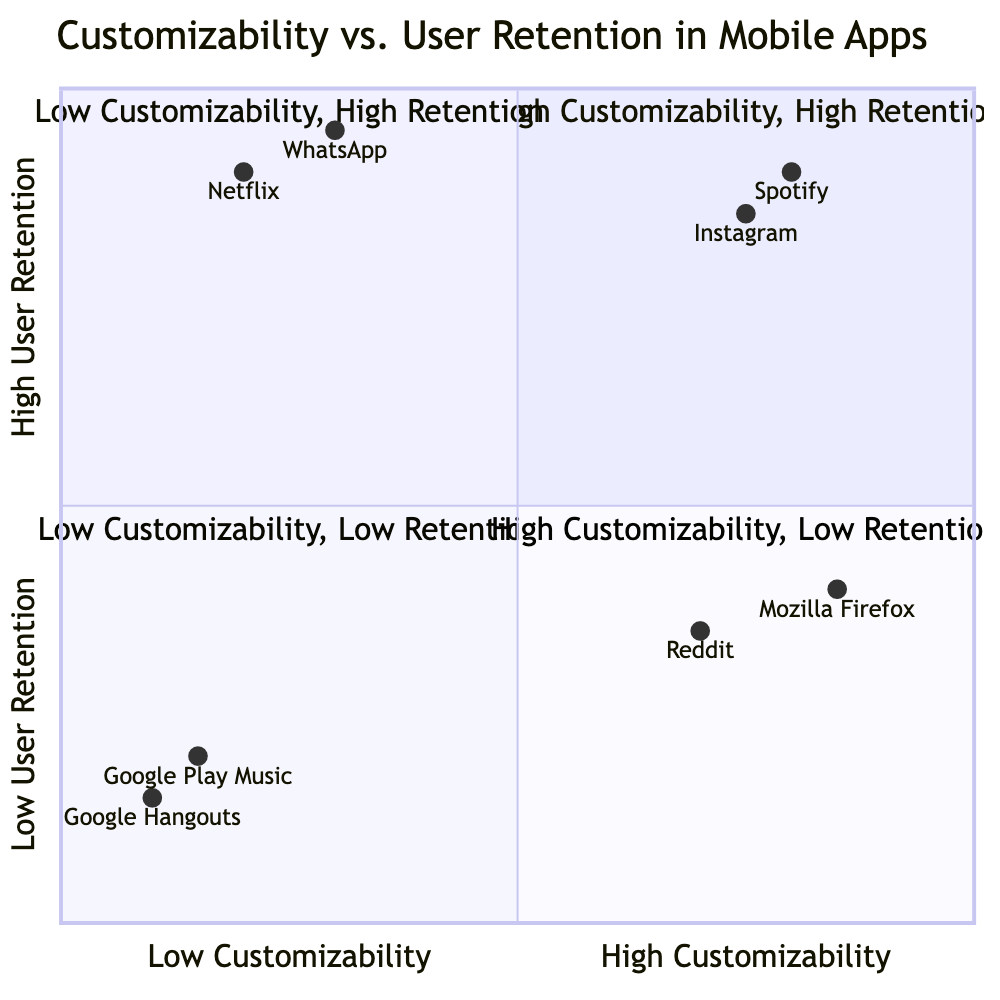What is the name of the app with high customizability and high user retention? The quadrant representing high customizability and high user retention contains the apps Spotify and Instagram.
Answer: Spotify, Instagram Which app shows high customizability but low user retention? The high customizability and low user retention quadrant includes Mozilla Firefox and Reddit.
Answer: Mozilla Firefox, Reddit How many apps are located in the low customizability and low user retention quadrant? The low customizability and low user retention quadrant features two apps: Google Play Music and Google Hangouts. This makes a total of 2 apps in this quadrant.
Answer: 2 What customization factor is provided by WhatsApp? WhatsApp's customizability factors include chat backgrounds and notification tones, but the specific customization factor asked for is chat backgrounds.
Answer: Chat Backgrounds What is the primary retention factor for Netflix? Netflix is known for its original content, which contributes significantly to user retention, along with a wide selection and high streaming quality. The answer sought here is original content.
Answer: Original Content How does Mozilla Firefox's user retention compare to Reddit's? Mozilla Firefox has lower user retention compared to Reddit, with retention factors influenced by security concerns and speed issues, while Reddit faces challenges due to toxicity in communities and an overwhelming interface. Since the question asks for the comparison, the answer is that Mozilla Firefox provides low user retention, and it is less than that of Reddit.
Answer: Lower Name the app in the low customizability and high user retention quadrant. The low customizability but high user retention quadrant contains WhatsApp and Netflix. The answer requested is the first one mentioned, which is WhatsApp.
Answer: WhatsApp What are the customizability factors for Instagram? Instagram offers several customizability factors, mainly filters, story highlights, and profile themes. The customizability factors of interest here are filters, story highlights, and profile themes.
Answer: Filters, Story Highlights, Profile Themes Which quadrant includes Google Hangouts? Google Hangouts is found in the low customizability and low user retention quadrant, alongside Google Play Music. The question asks for the specific quadrant, so the answer is low customizability, low user retention.
Answer: Low Customizability, Low User Retention What common factor affects both Mozilla Firefox and Reddit's user retention? Both Mozilla Firefox and Reddit face user retention issues due to their specific challenges; Firefox's issues stem from security concerns and speed, while Reddit’s stem from toxicity and content moderation issues. The overarching factor that affects both is that they suffer from user retention challenges.
Answer: User retention challenges 